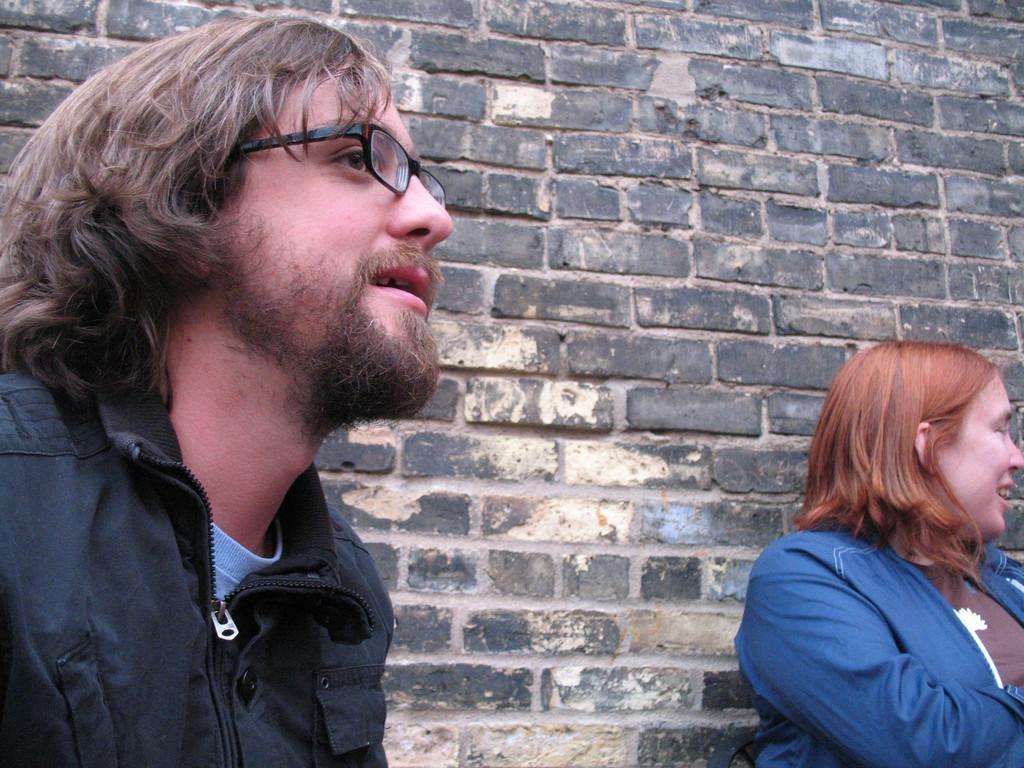Could you give a brief overview of what you see in this image? In this image I can see a man and a woman. I can see she is wearing blue colour jacket and he is wearing black colour jacket. I can also see he is wearing specs and in the background I can see a wall. 